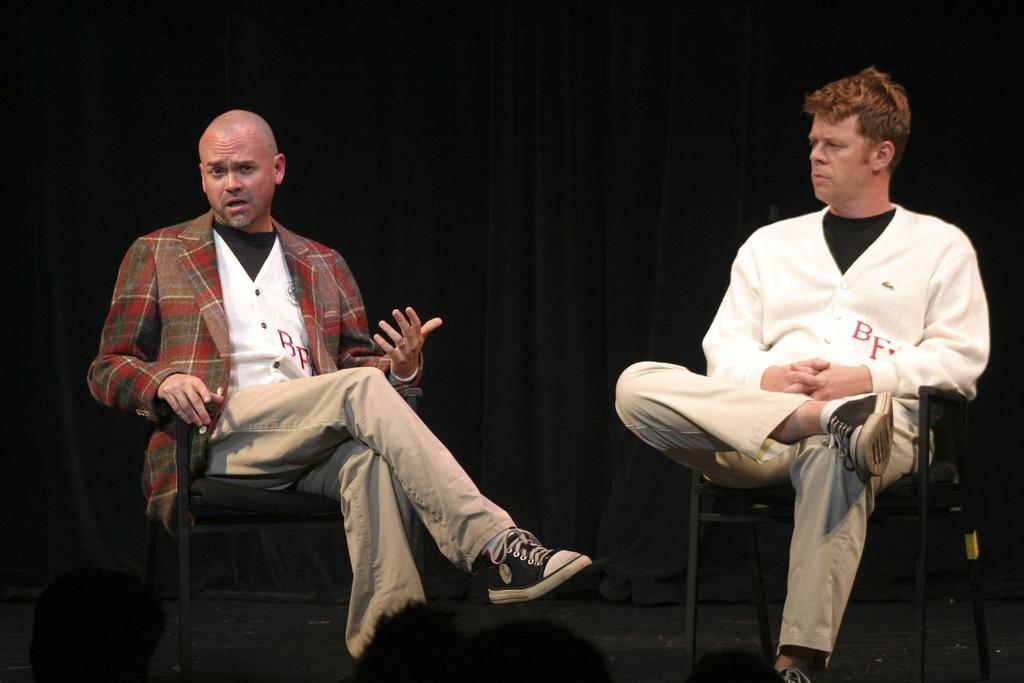How many people are in the image? There are two men in the image. What are the men doing in the image? The men are sitting on chairs. What can be seen in the background of the image? There is a curtain in the background of the image. What type of doll is sitting next to the men in the image? There is no doll present in the image; it only features two men sitting on chairs. 